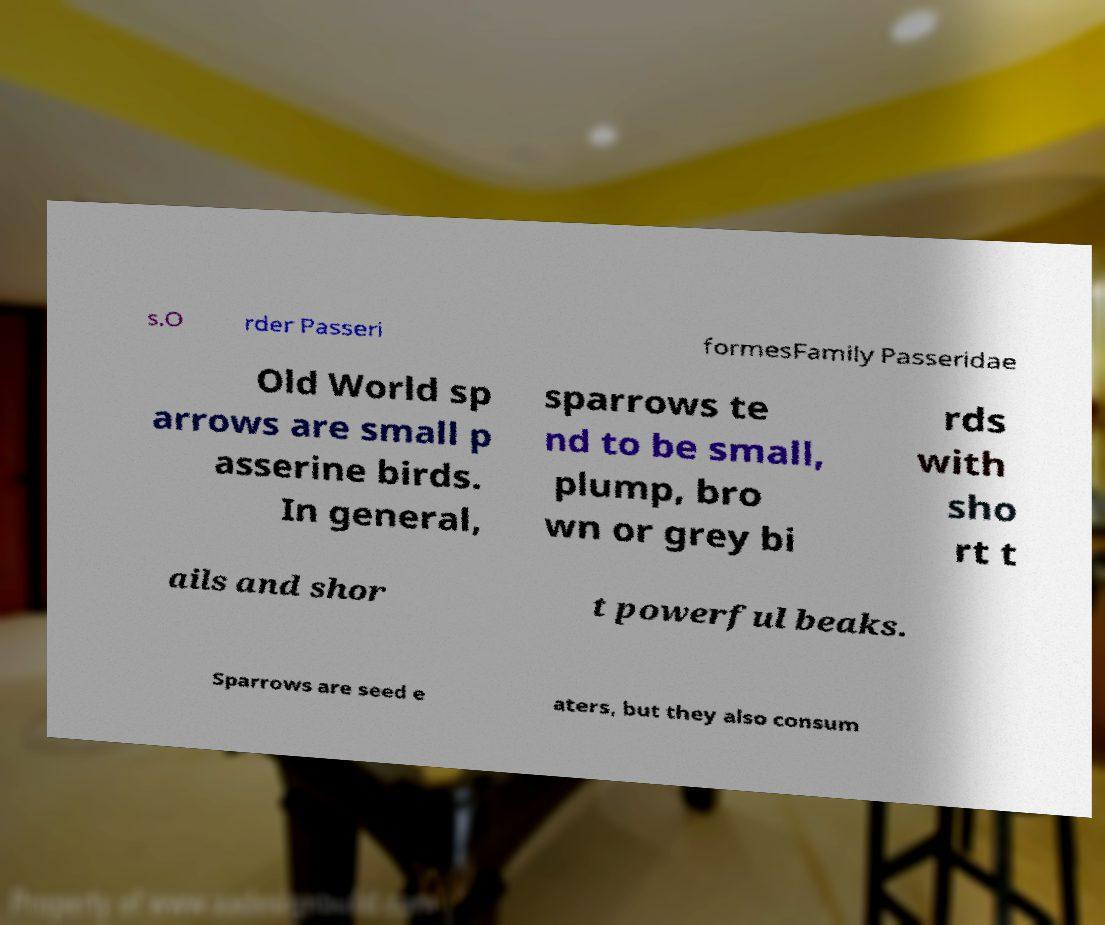Please identify and transcribe the text found in this image. s.O rder Passeri formesFamily Passeridae Old World sp arrows are small p asserine birds. In general, sparrows te nd to be small, plump, bro wn or grey bi rds with sho rt t ails and shor t powerful beaks. Sparrows are seed e aters, but they also consum 